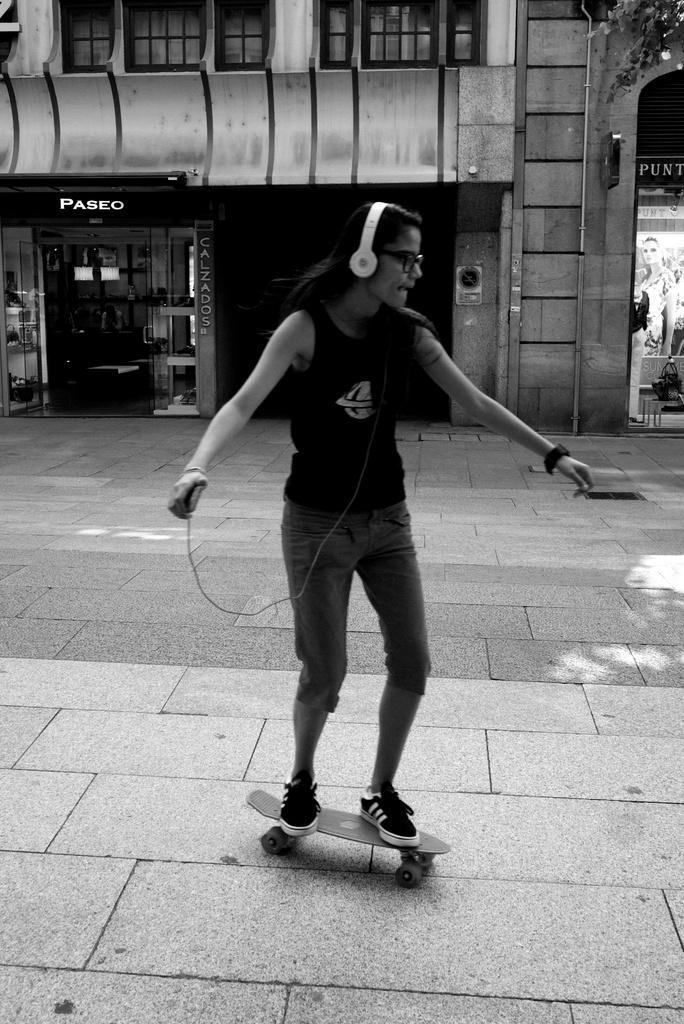Please provide a concise description of this image. This is a black and white image where we can see a woman wearing headsets and spectacles is holding a mobile phone and standing on the skateboard and skating on the road. In the background, we can see a building, board and glass doors. 